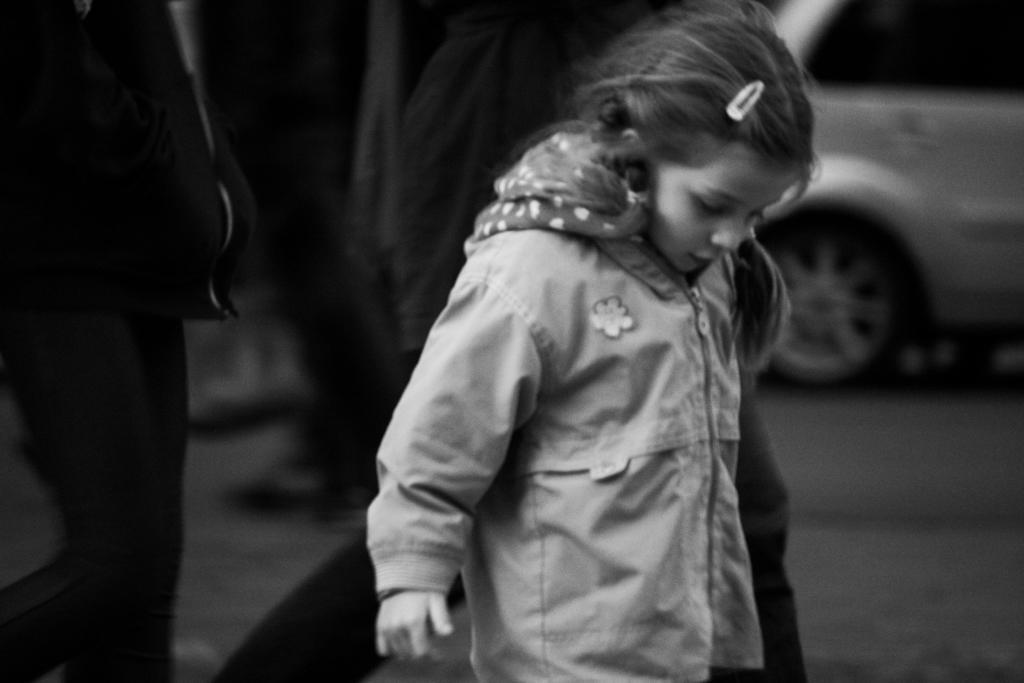Please provide a concise description of this image. It is the black and white image in which there is a girl in the middle. On the right side top there is a car. On the left side there are two other persons standing on the floor. 